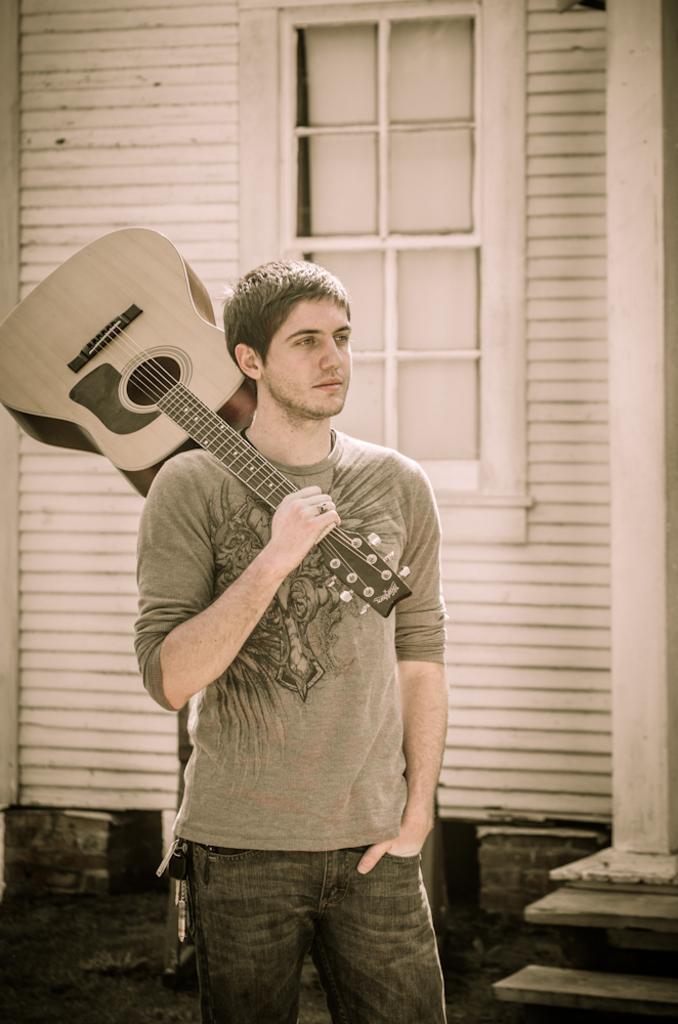What is the main subject of the picture? The main subject of the picture is a man. What is the man doing in the picture? The man is standing and holding a guitar on his shoulders. What is the man's purpose in the picture? The man is posing for a picture. What can be seen in the background of the picture? There is a window and a wall in the background of the picture. How far away is the passenger from the man in the picture? There is no passenger present in the image, so it is not possible to determine the distance between them. 